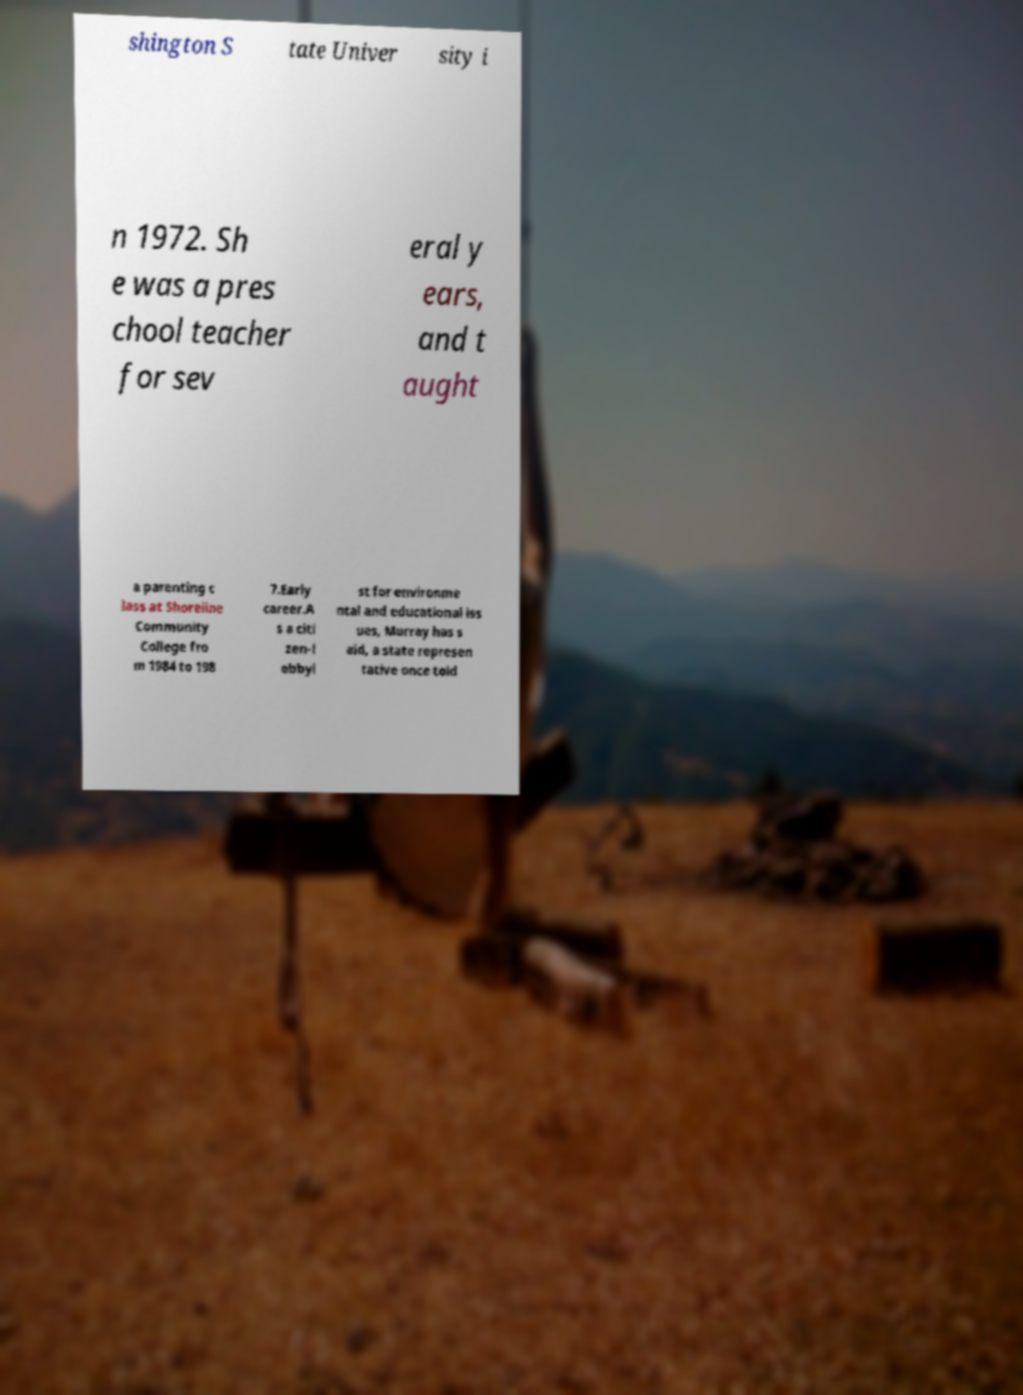Could you assist in decoding the text presented in this image and type it out clearly? shington S tate Univer sity i n 1972. Sh e was a pres chool teacher for sev eral y ears, and t aught a parenting c lass at Shoreline Community College fro m 1984 to 198 7.Early career.A s a citi zen-l obbyi st for environme ntal and educational iss ues, Murray has s aid, a state represen tative once told 